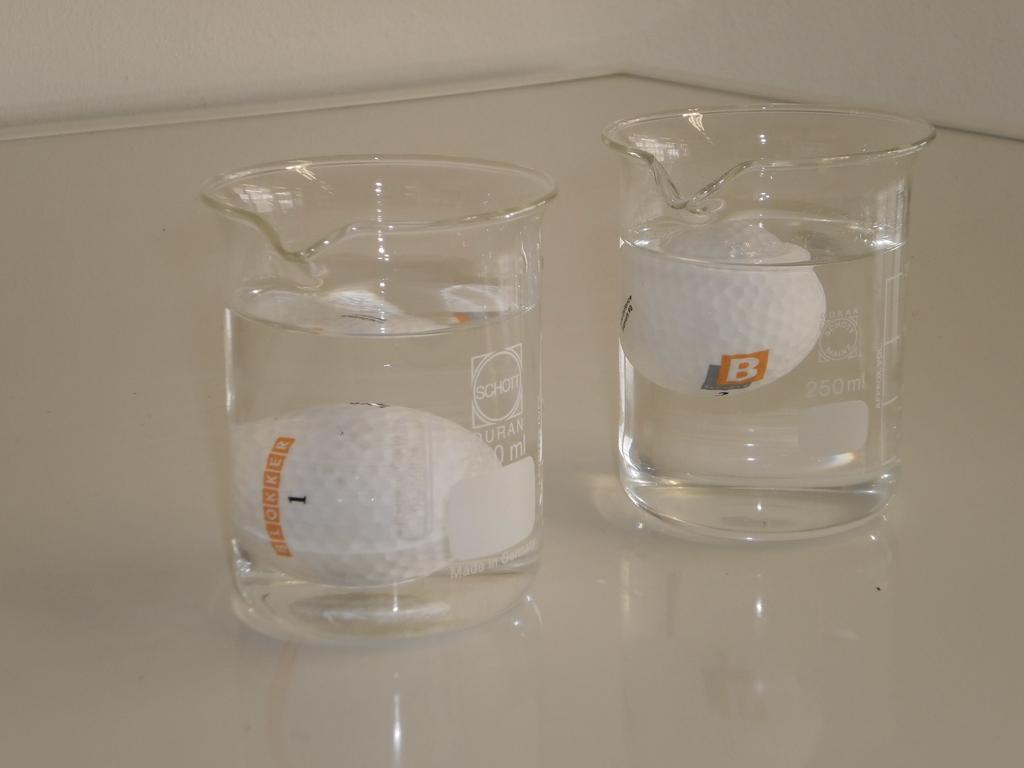<image>
Create a compact narrative representing the image presented. A golf ball with the word blokker on it is in a beaker full of water. 